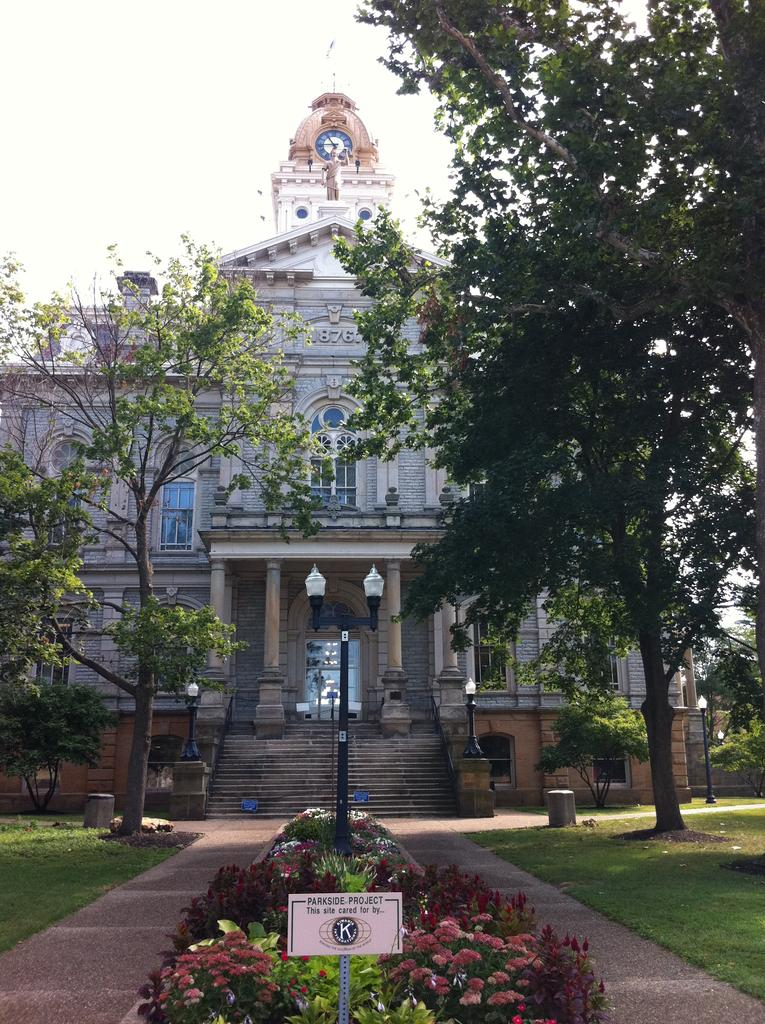<image>
Offer a succinct explanation of the picture presented. A photo of the Parkside Project that is cared for by the Kiwanias club. 